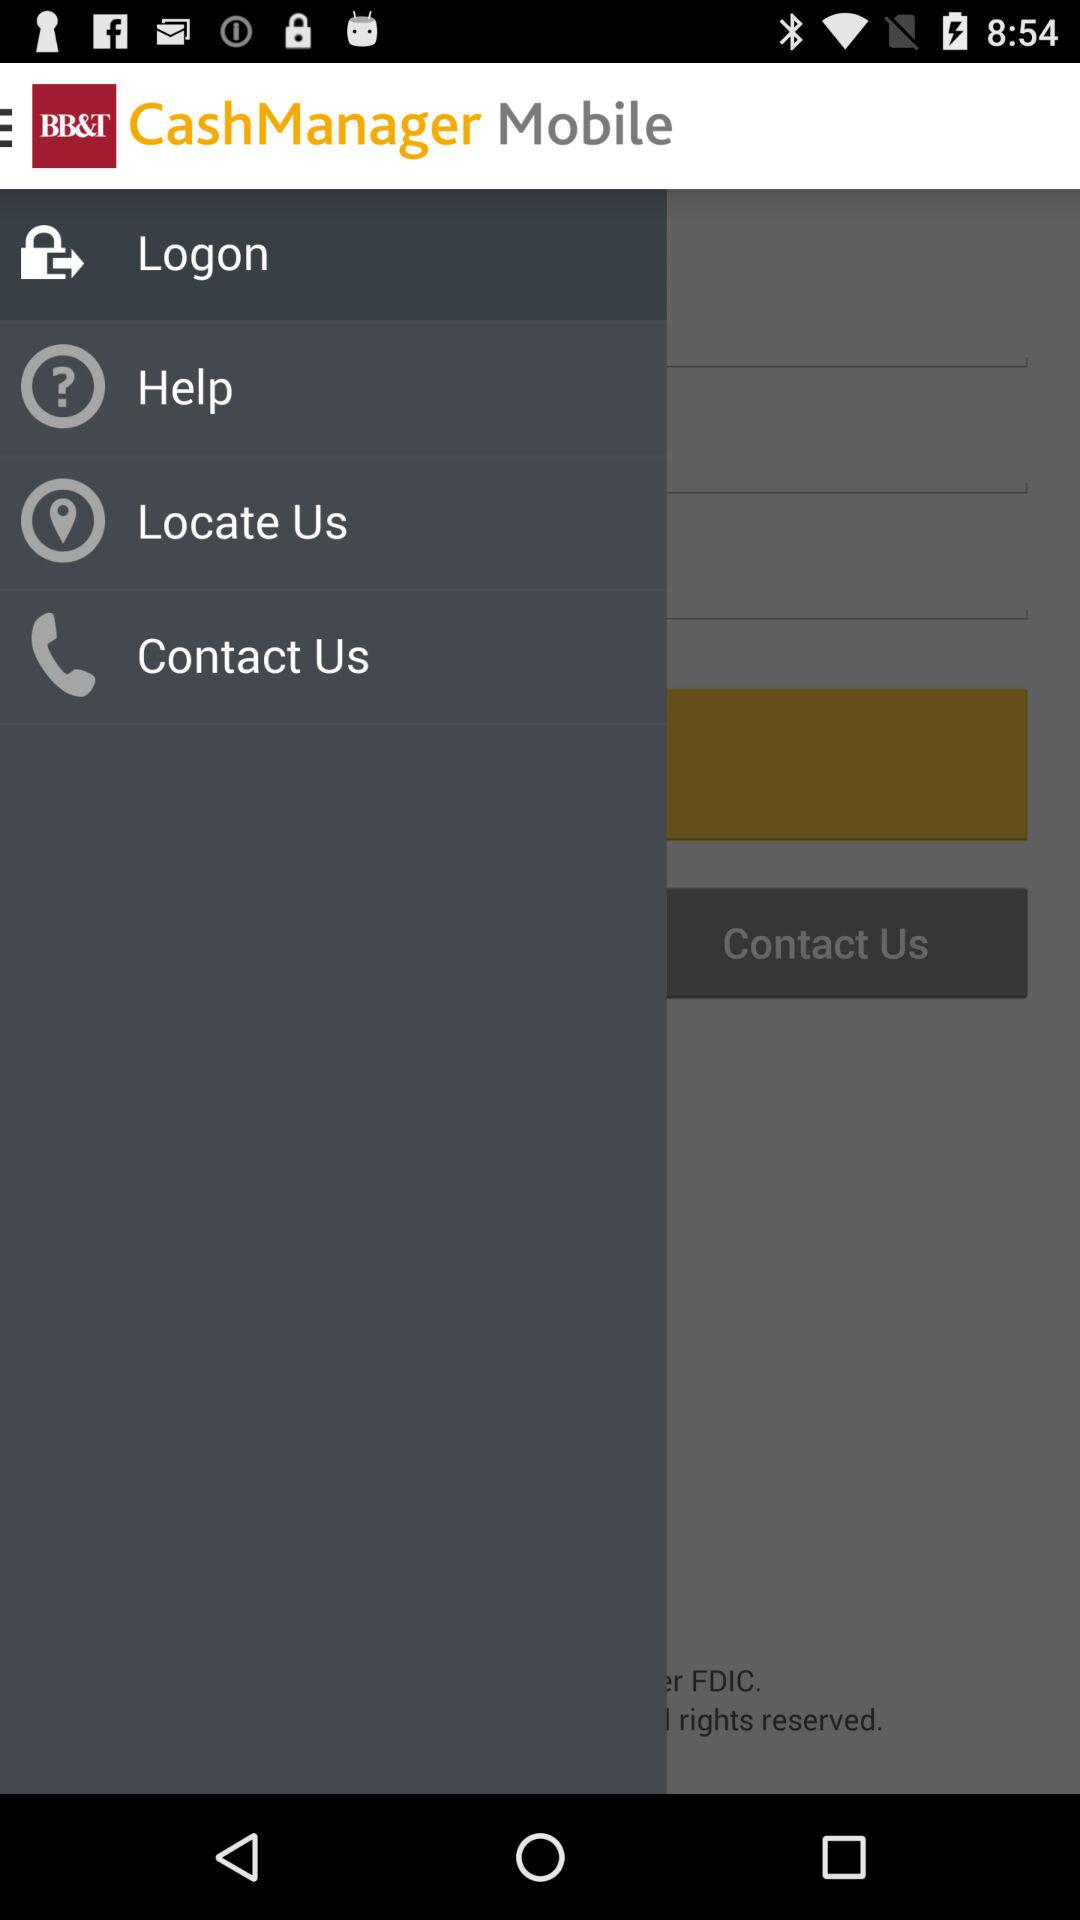What is the name of the application? The name of the application is "CashManager Mobile". 